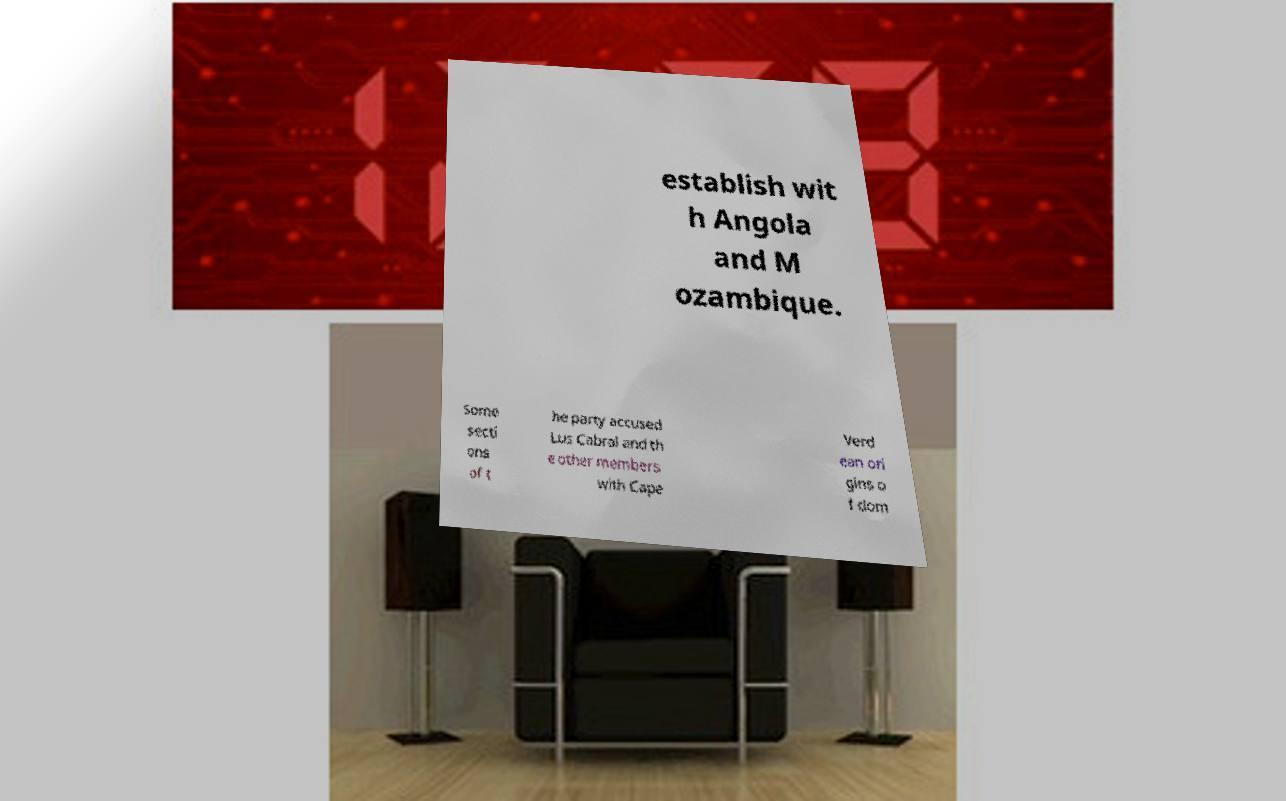Can you accurately transcribe the text from the provided image for me? establish wit h Angola and M ozambique. Some secti ons of t he party accused Lus Cabral and th e other members with Cape Verd ean ori gins o f dom 